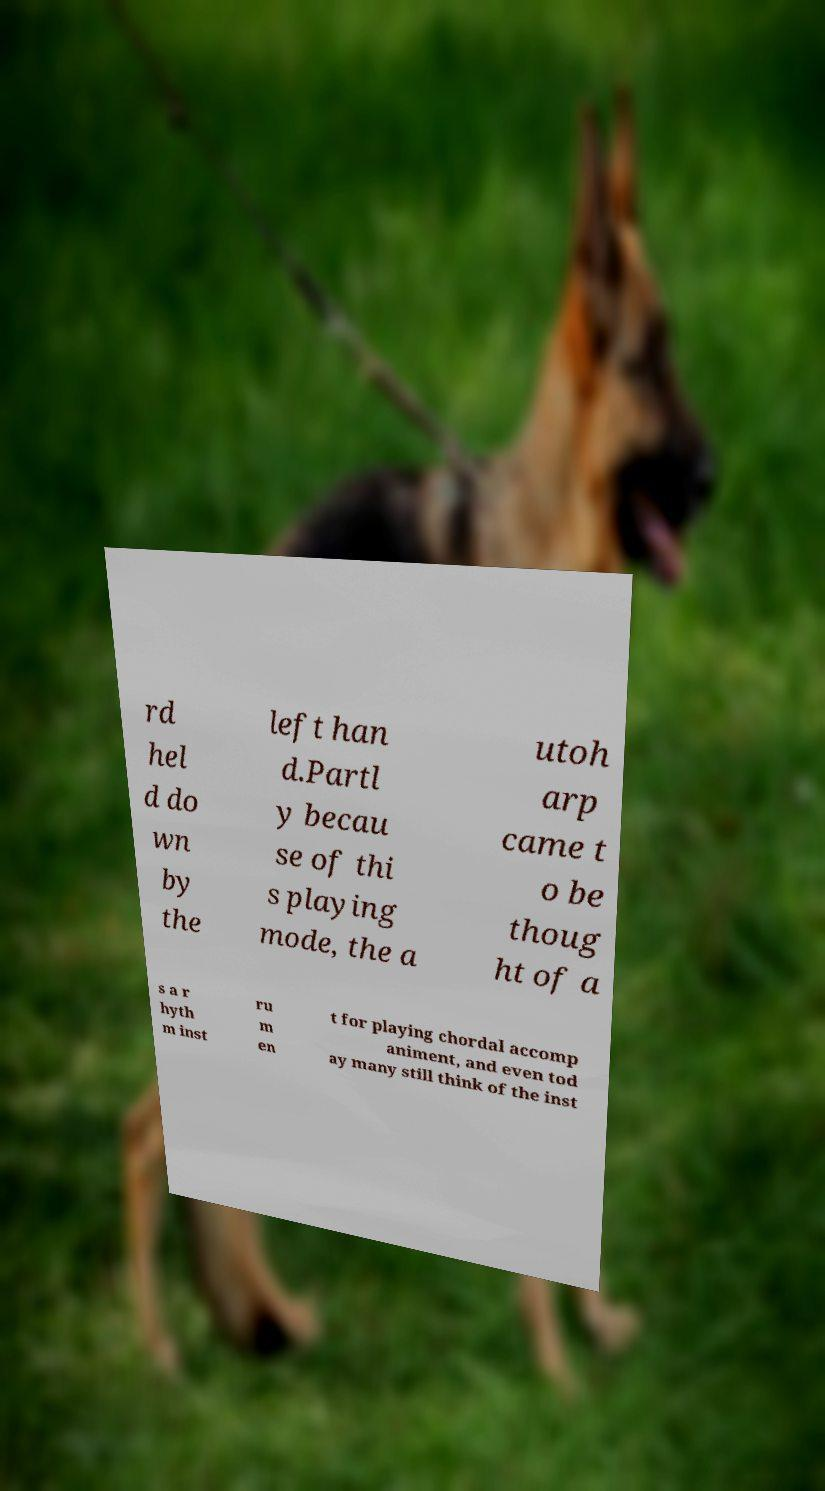Please identify and transcribe the text found in this image. rd hel d do wn by the left han d.Partl y becau se of thi s playing mode, the a utoh arp came t o be thoug ht of a s a r hyth m inst ru m en t for playing chordal accomp animent, and even tod ay many still think of the inst 